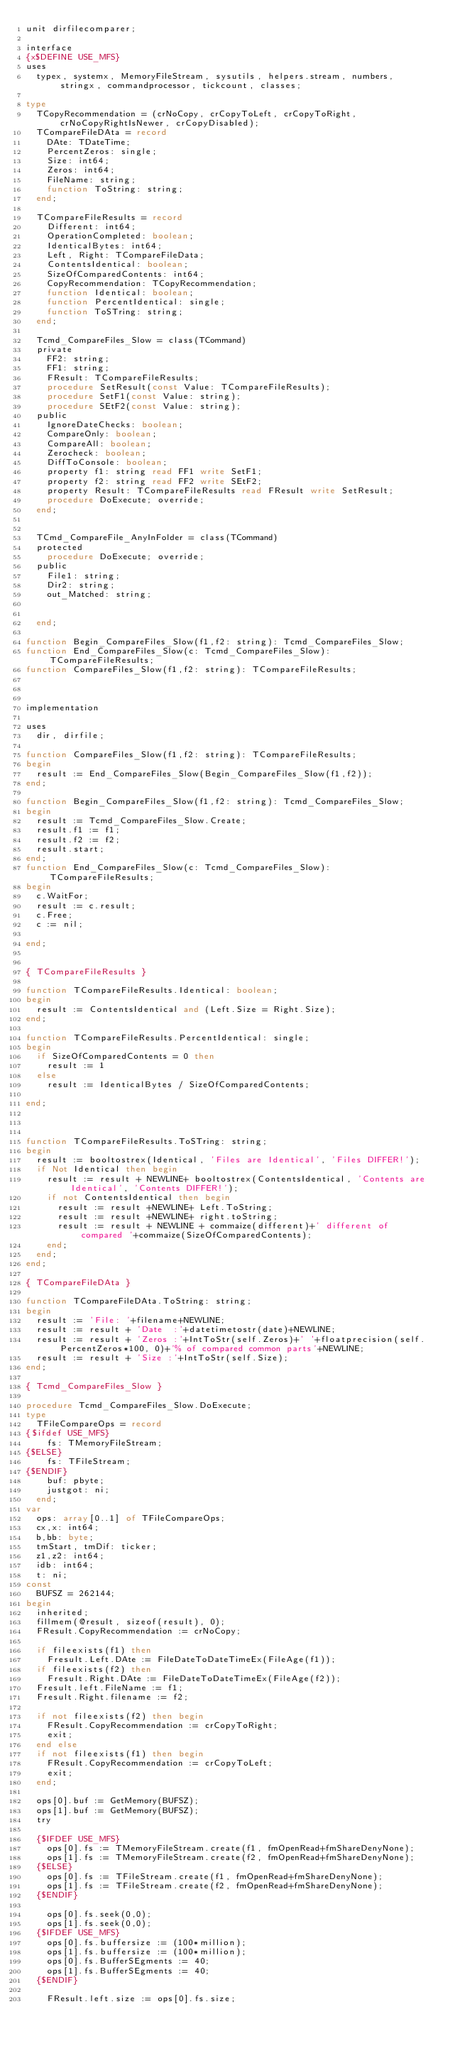<code> <loc_0><loc_0><loc_500><loc_500><_Pascal_>unit dirfilecomparer;

interface
{x$DEFINE USE_MFS}
uses
  typex, systemx, MemoryFileStream, sysutils, helpers.stream, numbers, stringx, commandprocessor, tickcount, classes;

type
  TCopyRecommendation = (crNoCopy, crCopyToLeft, crCopyToRight, crNoCopyRightIsNewer, crCopyDisabled);
  TCompareFileDAta = record
    DAte: TDateTime;
    PercentZeros: single;
    Size: int64;
    Zeros: int64;
    FileName: string;
    function ToString: string;
  end;

  TCompareFileResults = record
    Different: int64;
    OperationCompleted: boolean;
    IdenticalBytes: int64;
    Left, Right: TCompareFileData;
    ContentsIdentical: boolean;
    SizeOfComparedContents: int64;
    CopyRecommendation: TCopyRecommendation;
    function Identical: boolean;
    function PercentIdentical: single;
    function ToSTring: string;
  end;

  Tcmd_CompareFiles_Slow = class(TCommand)
  private
    FF2: string;
    FF1: string;
    FResult: TCompareFileResults;
    procedure SetResult(const Value: TCompareFileResults);
    procedure SetF1(const Value: string);
    procedure SEtF2(const Value: string);
  public
    IgnoreDateChecks: boolean;
    CompareOnly: boolean;
    CompareAll: boolean;
    Zerocheck: boolean;
    DiffToConsole: boolean;
    property f1: string read FF1 write SetF1;
    property f2: string read FF2 write SEtF2;
    property Result: TCompareFileResults read FResult write SetResult;
    procedure DoExecute; override;
  end;


  TCmd_CompareFile_AnyInFolder = class(TCommand)
  protected
    procedure DoExecute; override;
  public
    File1: string;
    Dir2: string;
    out_Matched: string;


  end;

function Begin_CompareFiles_Slow(f1,f2: string): Tcmd_CompareFiles_Slow;
function End_CompareFiles_Slow(c: Tcmd_CompareFiles_Slow): TCompareFileResults;
function CompareFiles_Slow(f1,f2: string): TCompareFileResults;



implementation

uses
  dir, dirfile;

function CompareFiles_Slow(f1,f2: string): TCompareFileResults;
begin
  result := End_CompareFiles_Slow(Begin_CompareFiles_Slow(f1,f2));
end;

function Begin_CompareFiles_Slow(f1,f2: string): Tcmd_CompareFiles_Slow;
begin
  result := Tcmd_CompareFiles_Slow.Create;
  result.f1 := f1;
  result.f2 := f2;
  result.start;
end;
function End_CompareFiles_Slow(c: Tcmd_CompareFiles_Slow): TCompareFileResults;
begin
  c.WaitFor;
  result := c.result;
  c.Free;
  c := nil;

end;


{ TCompareFileResults }

function TCompareFileResults.Identical: boolean;
begin
  result := ContentsIdentical and (Left.Size = Right.Size);
end;

function TCompareFileResults.PercentIdentical: single;
begin
  if SizeOfComparedContents = 0 then
    result := 1
  else
    result := IdenticalBytes / SizeOfComparedContents;

end;



function TCompareFileResults.ToSTring: string;
begin
  result := booltostrex(Identical, 'Files are Identical', 'Files DIFFER!');
  if Not Identical then begin
    result := result + NEWLINE+ booltostrex(ContentsIdentical, 'Contents are Identical', 'Contents DIFFER!');
    if not ContentsIdentical then begin
      result := result +NEWLINE+ Left.ToString;
      result := result +NEWLINE+ right.toString;
      result := result + NEWLINE + commaize(different)+' different of compared '+commaize(SizeOfComparedContents);
    end;
  end;
end;

{ TCompareFileDAta }

function TCompareFileDAta.ToString: string;
begin
  result := 'File: '+filename+NEWLINE;
  result := result + 'Date  :'+datetimetostr(date)+NEWLINE;
  result := result + 'Zeros :'+IntToStr(self.Zeros)+' '+floatprecision(self.PercentZeros*100, 0)+'% of compared common parts'+NEWLINE;
  result := result + 'Size :'+IntToStr(self.Size);
end;

{ Tcmd_CompareFiles_Slow }

procedure Tcmd_CompareFiles_Slow.DoExecute;
type
  TFileCompareOps = record
{$ifdef USE_MFS}
    fs: TMemoryFileStream;
{$ELSE}
    fs: TFileStream;
{$ENDIF}
    buf: pbyte;
    justgot: ni;
  end;
var
  ops: array[0..1] of TFileCompareOps;
  cx,x: int64;
  b,bb: byte;
  tmStart, tmDif: ticker;
  z1,z2: int64;
  idb: int64;
  t: ni;
const
  BUFSZ = 262144;
begin
  inherited;
  fillmem(@result, sizeof(result), 0);
  FResult.CopyRecommendation := crNoCopy;

  if fileexists(f1) then
    Fresult.Left.DAte := FileDateToDateTimeEx(FileAge(f1));
  if fileexists(f2) then
    Fresult.Right.DAte := FileDateToDateTimeEx(FileAge(f2));
  Fresult.left.FileName := f1;
  Fresult.Right.filename := f2;

  if not fileexists(f2) then begin
    FResult.CopyRecommendation := crCopyToRight;
    exit;
  end else
  if not fileexists(f1) then begin
    FResult.CopyRecommendation := crCopyToLeft;
    exit;
  end;

  ops[0].buf := GetMemory(BUFSZ);
  ops[1].buf := GetMemory(BUFSZ);
  try

  {$IFDEF USE_MFS}
    ops[0].fs := TMemoryFileStream.create(f1, fmOpenRead+fmShareDenyNone);
    ops[1].fs := TMemoryFileStream.create(f2, fmOpenRead+fmShareDenyNone);
  {$ELSE}
    ops[0].fs := TFileStream.create(f1, fmOpenRead+fmShareDenyNone);
    ops[1].fs := TFileStream.create(f2, fmOpenRead+fmShareDenyNone);
  {$ENDIF}

    ops[0].fs.seek(0,0);
    ops[1].fs.seek(0,0);
  {$IFDEF USE_MFS}
    ops[0].fs.buffersize := (100*million);
    ops[1].fs.buffersize := (100*million);
    ops[0].fs.BufferSEgments := 40;
    ops[1].fs.BufferSEgments := 40;
  {$ENDIF}

    FResult.left.size := ops[0].fs.size;</code> 